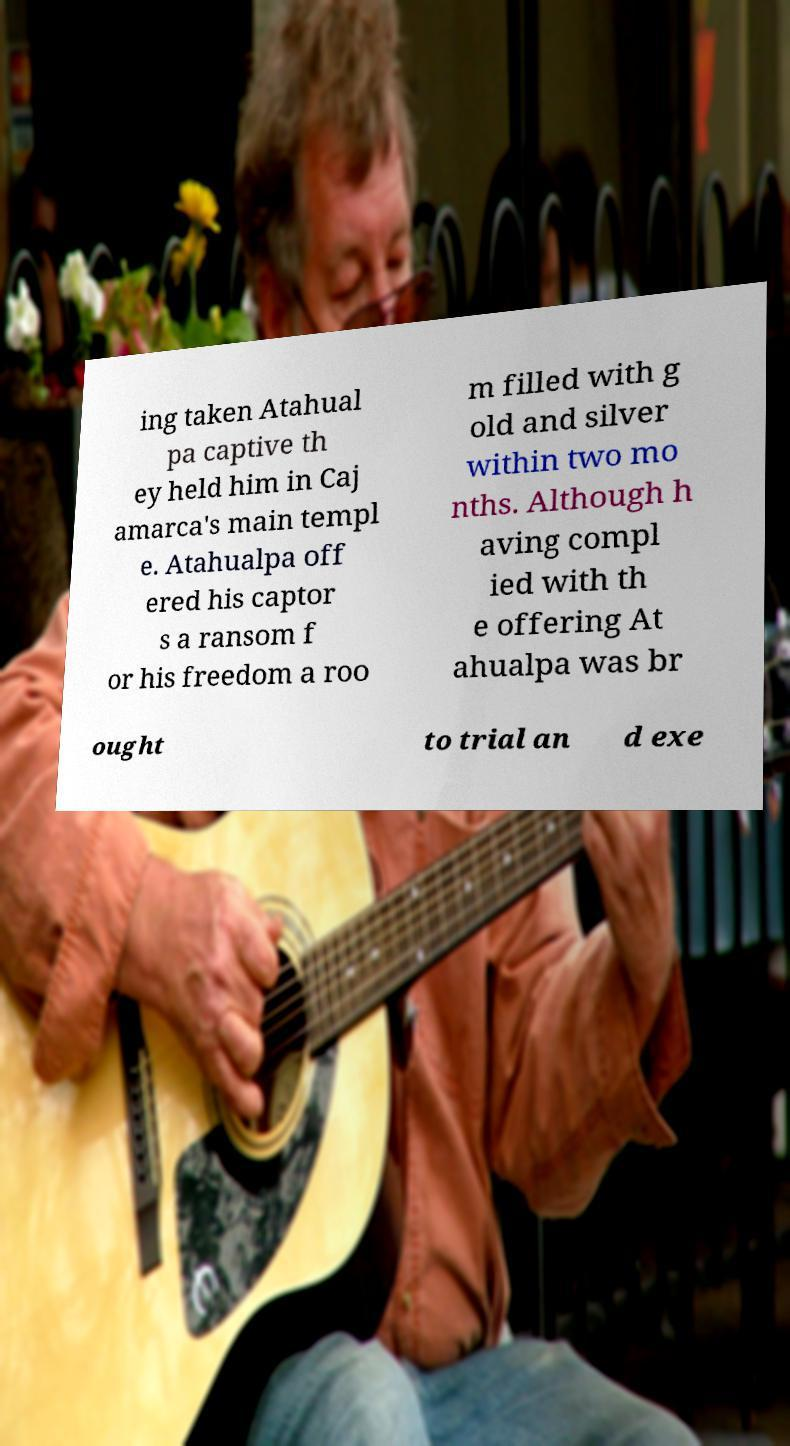Please read and relay the text visible in this image. What does it say? ing taken Atahual pa captive th ey held him in Caj amarca's main templ e. Atahualpa off ered his captor s a ransom f or his freedom a roo m filled with g old and silver within two mo nths. Although h aving compl ied with th e offering At ahualpa was br ought to trial an d exe 